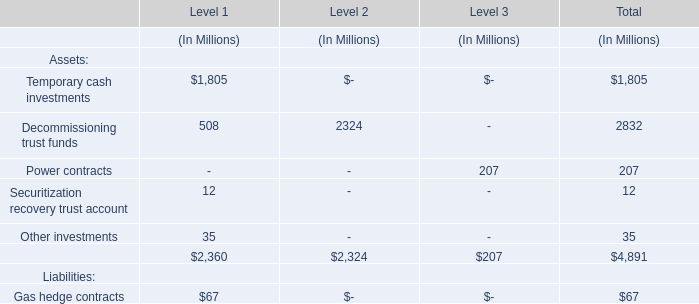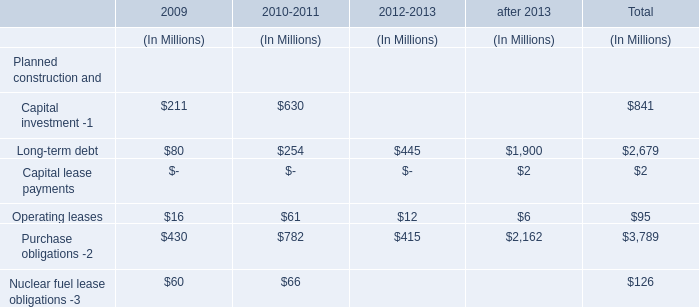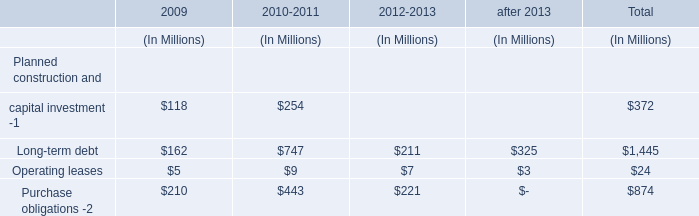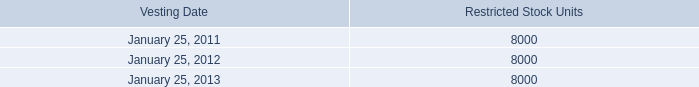What is the sum of the Temporary cash investments in the sections where Decommissioning trust funds is positive? (in Million) 
Computations: (1805 + 0)
Answer: 1805.0. 